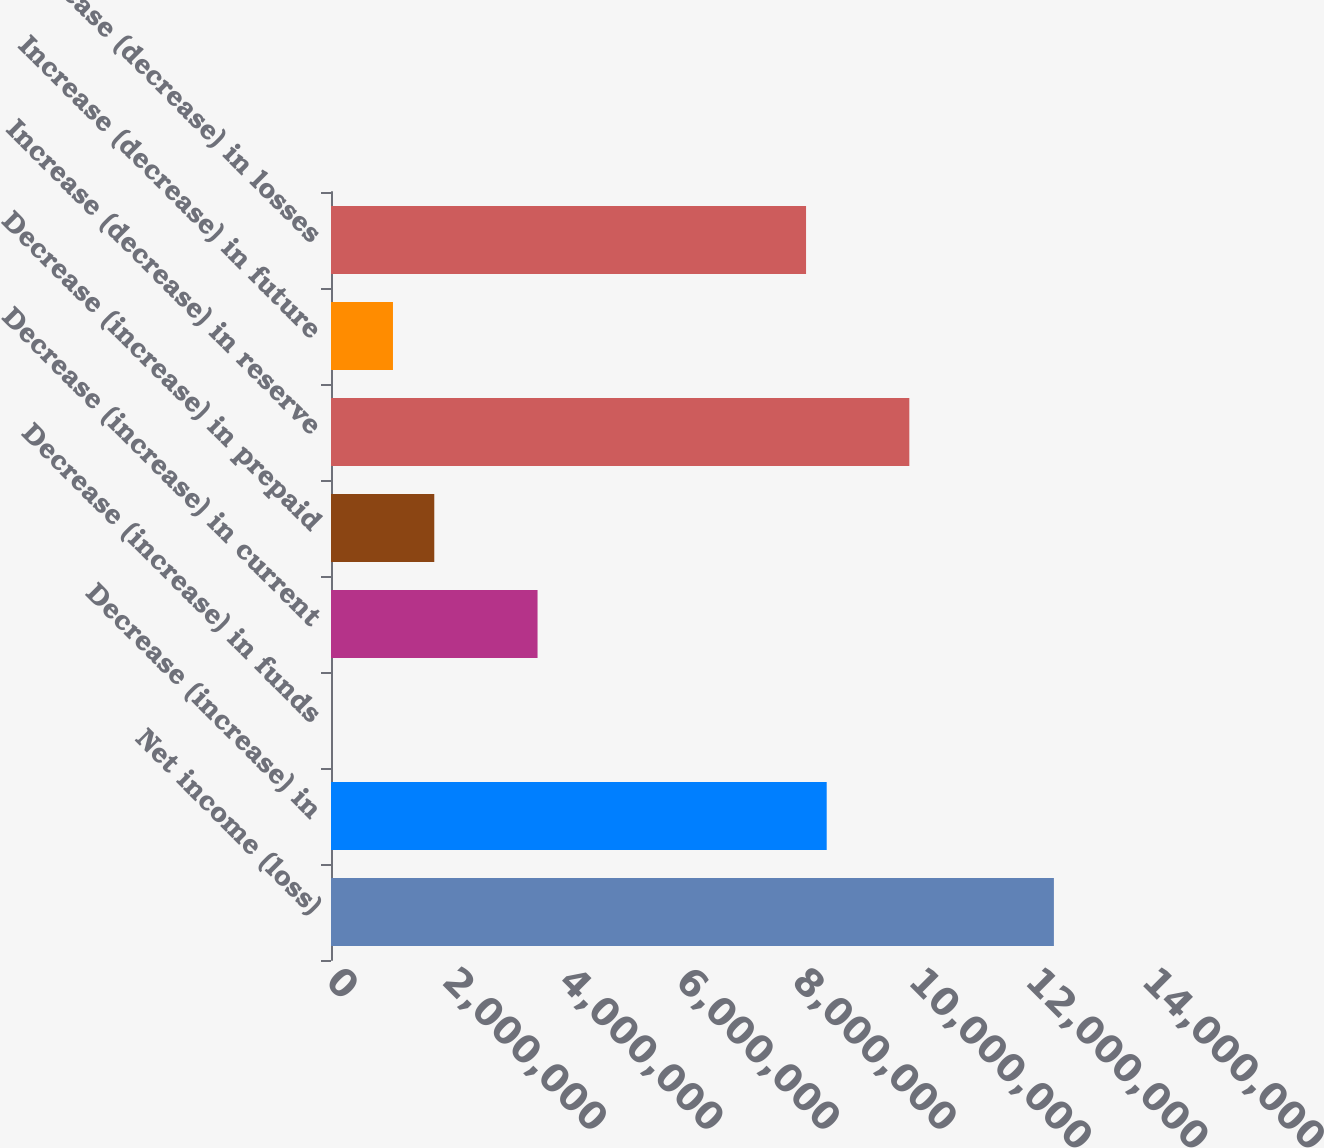Convert chart to OTSL. <chart><loc_0><loc_0><loc_500><loc_500><bar_chart><fcel>Net income (loss)<fcel>Decrease (increase) in<fcel>Decrease (increase) in funds<fcel>Decrease (increase) in current<fcel>Decrease (increase) in prepaid<fcel>Increase (decrease) in reserve<fcel>Increase (decrease) in future<fcel>Increase (decrease) in losses<nl><fcel>1.24028e+07<fcel>8.50484e+06<fcel>162<fcel>3.54378e+06<fcel>1.77197e+06<fcel>9.92228e+06<fcel>1.06325e+06<fcel>8.15047e+06<nl></chart> 